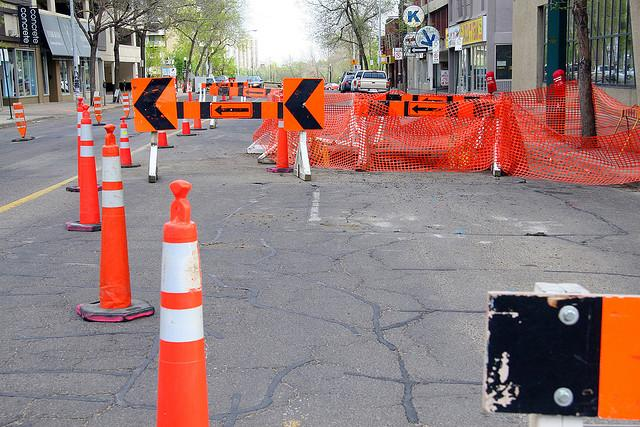Where are repairs taking place here? Please explain your reasoning. street. The asphalt and yellow lines indicate that this is a street. 